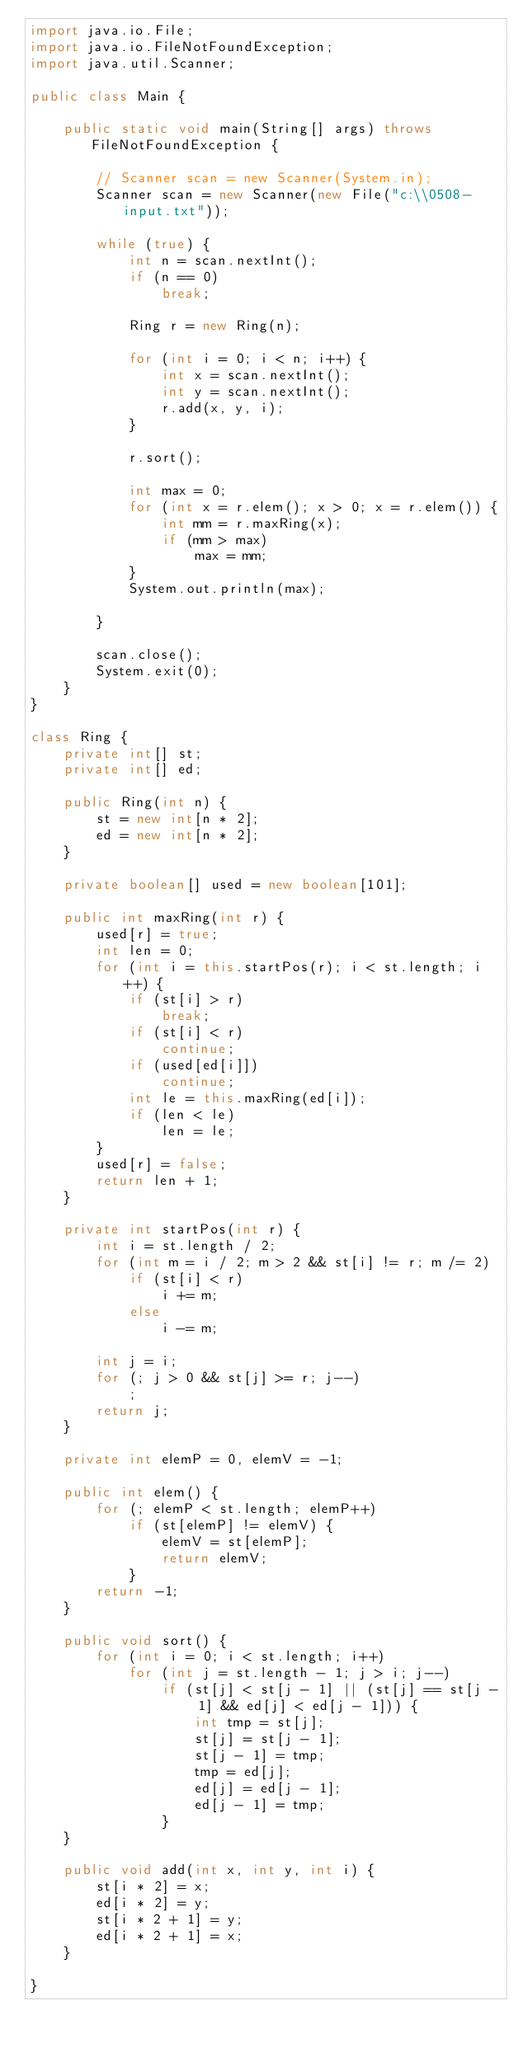<code> <loc_0><loc_0><loc_500><loc_500><_Java_>import java.io.File;
import java.io.FileNotFoundException;
import java.util.Scanner;

public class Main {

	public static void main(String[] args) throws FileNotFoundException {

		// Scanner scan = new Scanner(System.in);
		Scanner scan = new Scanner(new File("c:\\0508-input.txt"));

		while (true) {
			int n = scan.nextInt();
			if (n == 0)
				break;

			Ring r = new Ring(n);

			for (int i = 0; i < n; i++) {
				int x = scan.nextInt();
				int y = scan.nextInt();
				r.add(x, y, i);
			}

			r.sort();

			int max = 0;
			for (int x = r.elem(); x > 0; x = r.elem()) {
				int mm = r.maxRing(x);
				if (mm > max)
					max = mm;
			}
			System.out.println(max);

		}

		scan.close();
		System.exit(0);
	}
}

class Ring {
	private int[] st;
	private int[] ed;

	public Ring(int n) {
		st = new int[n * 2];
		ed = new int[n * 2];
	}

	private boolean[] used = new boolean[101];

	public int maxRing(int r) {
		used[r] = true;
		int len = 0;
		for (int i = this.startPos(r); i < st.length; i++) {
			if (st[i] > r)
				break;
			if (st[i] < r)
				continue;
			if (used[ed[i]])
				continue;
			int le = this.maxRing(ed[i]);
			if (len < le)
				len = le;
		}
		used[r] = false;
		return len + 1;
	}

	private int startPos(int r) {
		int i = st.length / 2;
		for (int m = i / 2; m > 2 && st[i] != r; m /= 2)
			if (st[i] < r)
				i += m;
			else
				i -= m;

		int j = i;
		for (; j > 0 && st[j] >= r; j--)
			;
		return j;
	}

	private int elemP = 0, elemV = -1;

	public int elem() {
		for (; elemP < st.length; elemP++)
			if (st[elemP] != elemV) {
				elemV = st[elemP];
				return elemV;
			}
		return -1;
	}

	public void sort() {
		for (int i = 0; i < st.length; i++)
			for (int j = st.length - 1; j > i; j--)
				if (st[j] < st[j - 1] || (st[j] == st[j - 1] && ed[j] < ed[j - 1])) {
					int tmp = st[j];
					st[j] = st[j - 1];
					st[j - 1] = tmp;
					tmp = ed[j];
					ed[j] = ed[j - 1];
					ed[j - 1] = tmp;
				}
	}

	public void add(int x, int y, int i) {
		st[i * 2] = x;
		ed[i * 2] = y;
		st[i * 2 + 1] = y;
		ed[i * 2 + 1] = x;
	}

}</code> 